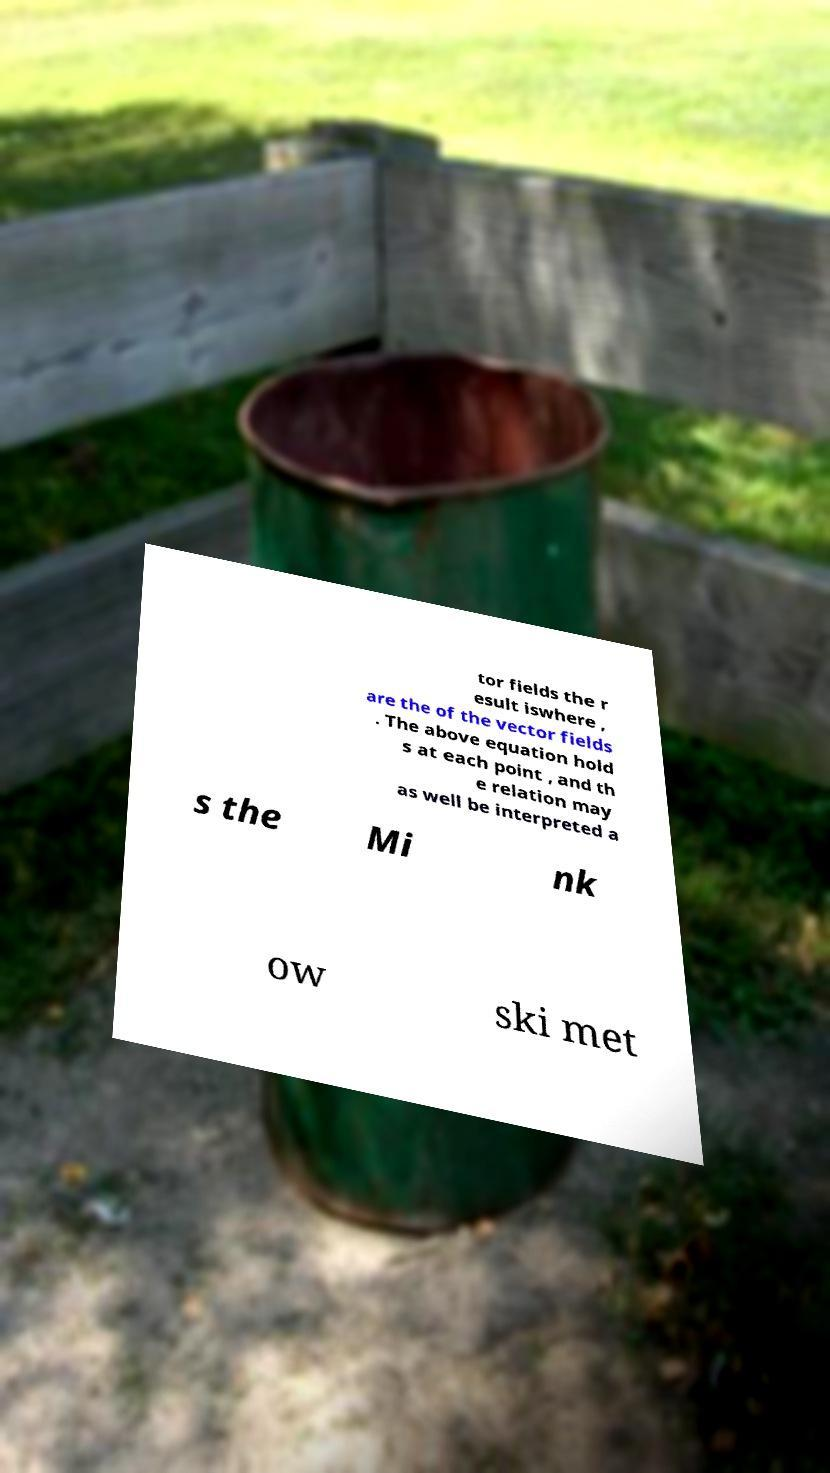Please identify and transcribe the text found in this image. tor fields the r esult iswhere , are the of the vector fields . The above equation hold s at each point , and th e relation may as well be interpreted a s the Mi nk ow ski met 